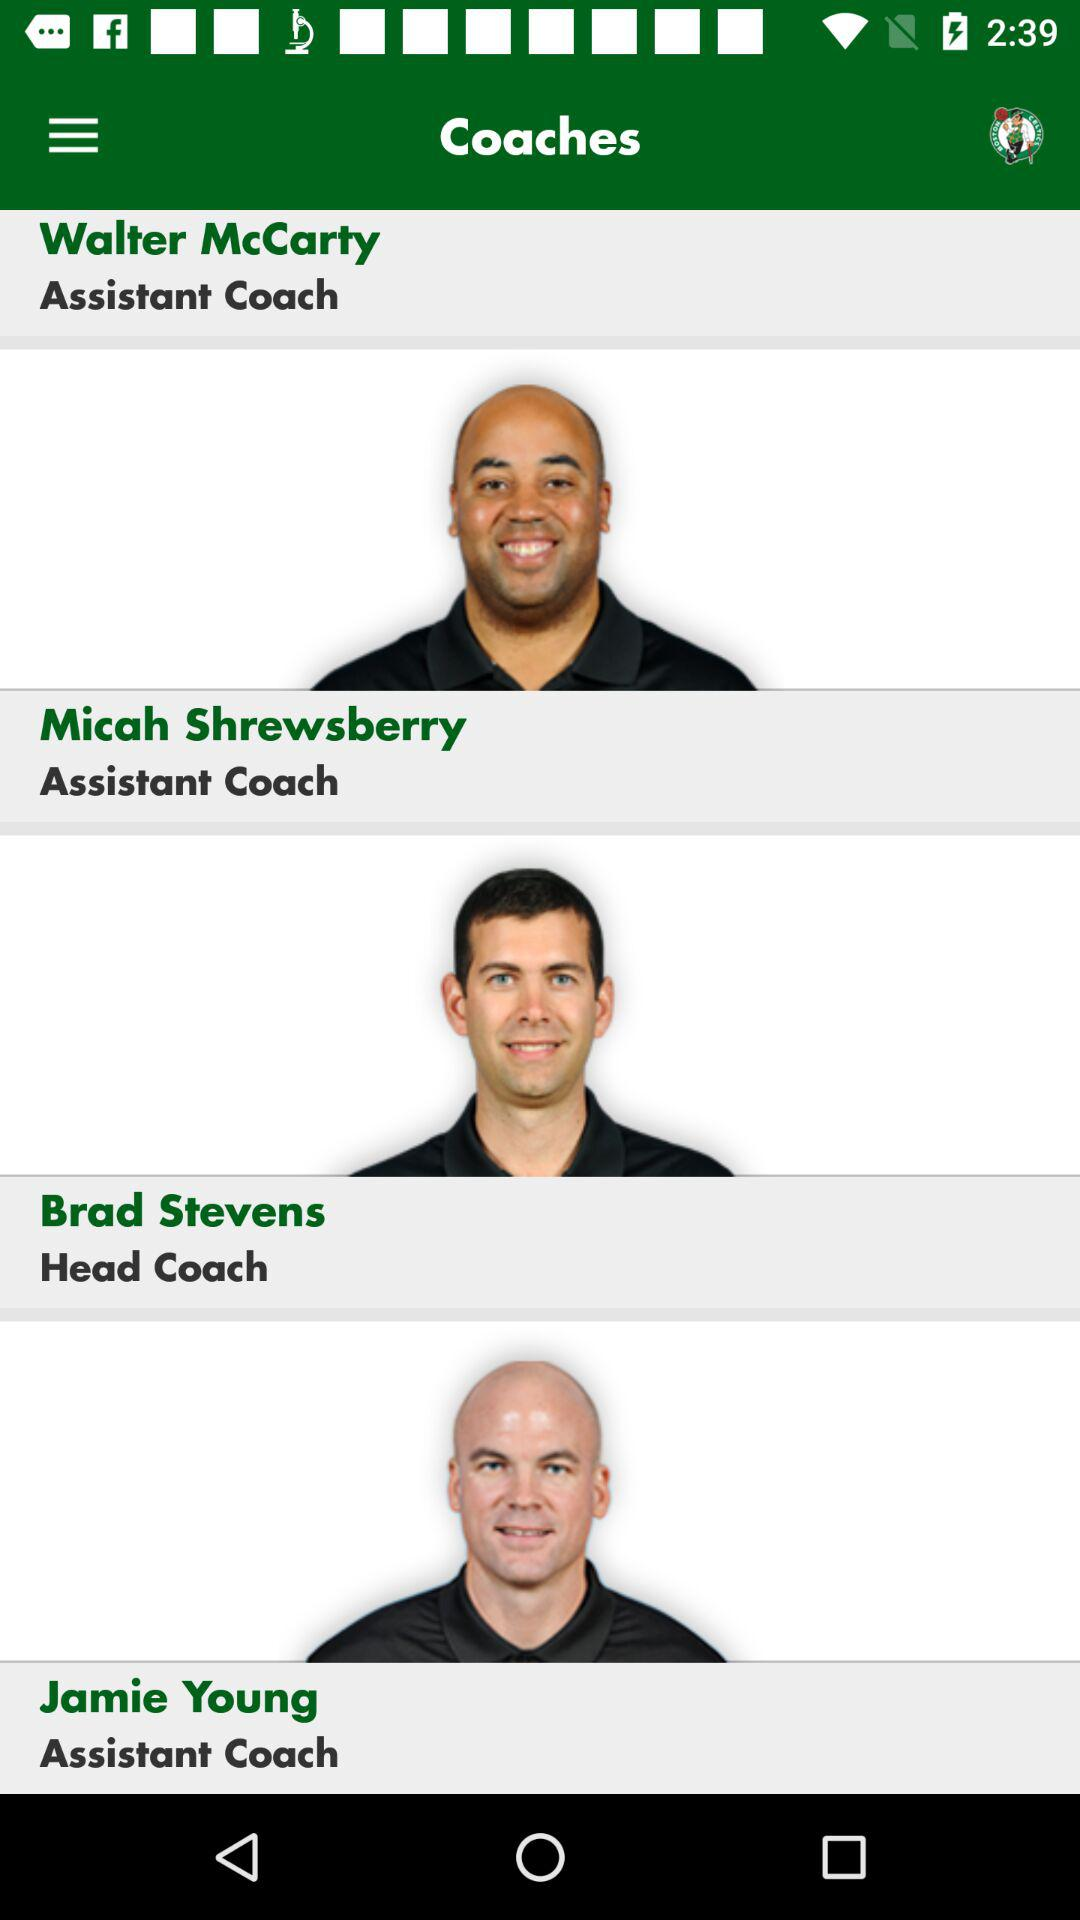To what post is Jamie Young appointed? Jamie Young has been appointed as Assistant Coach. 